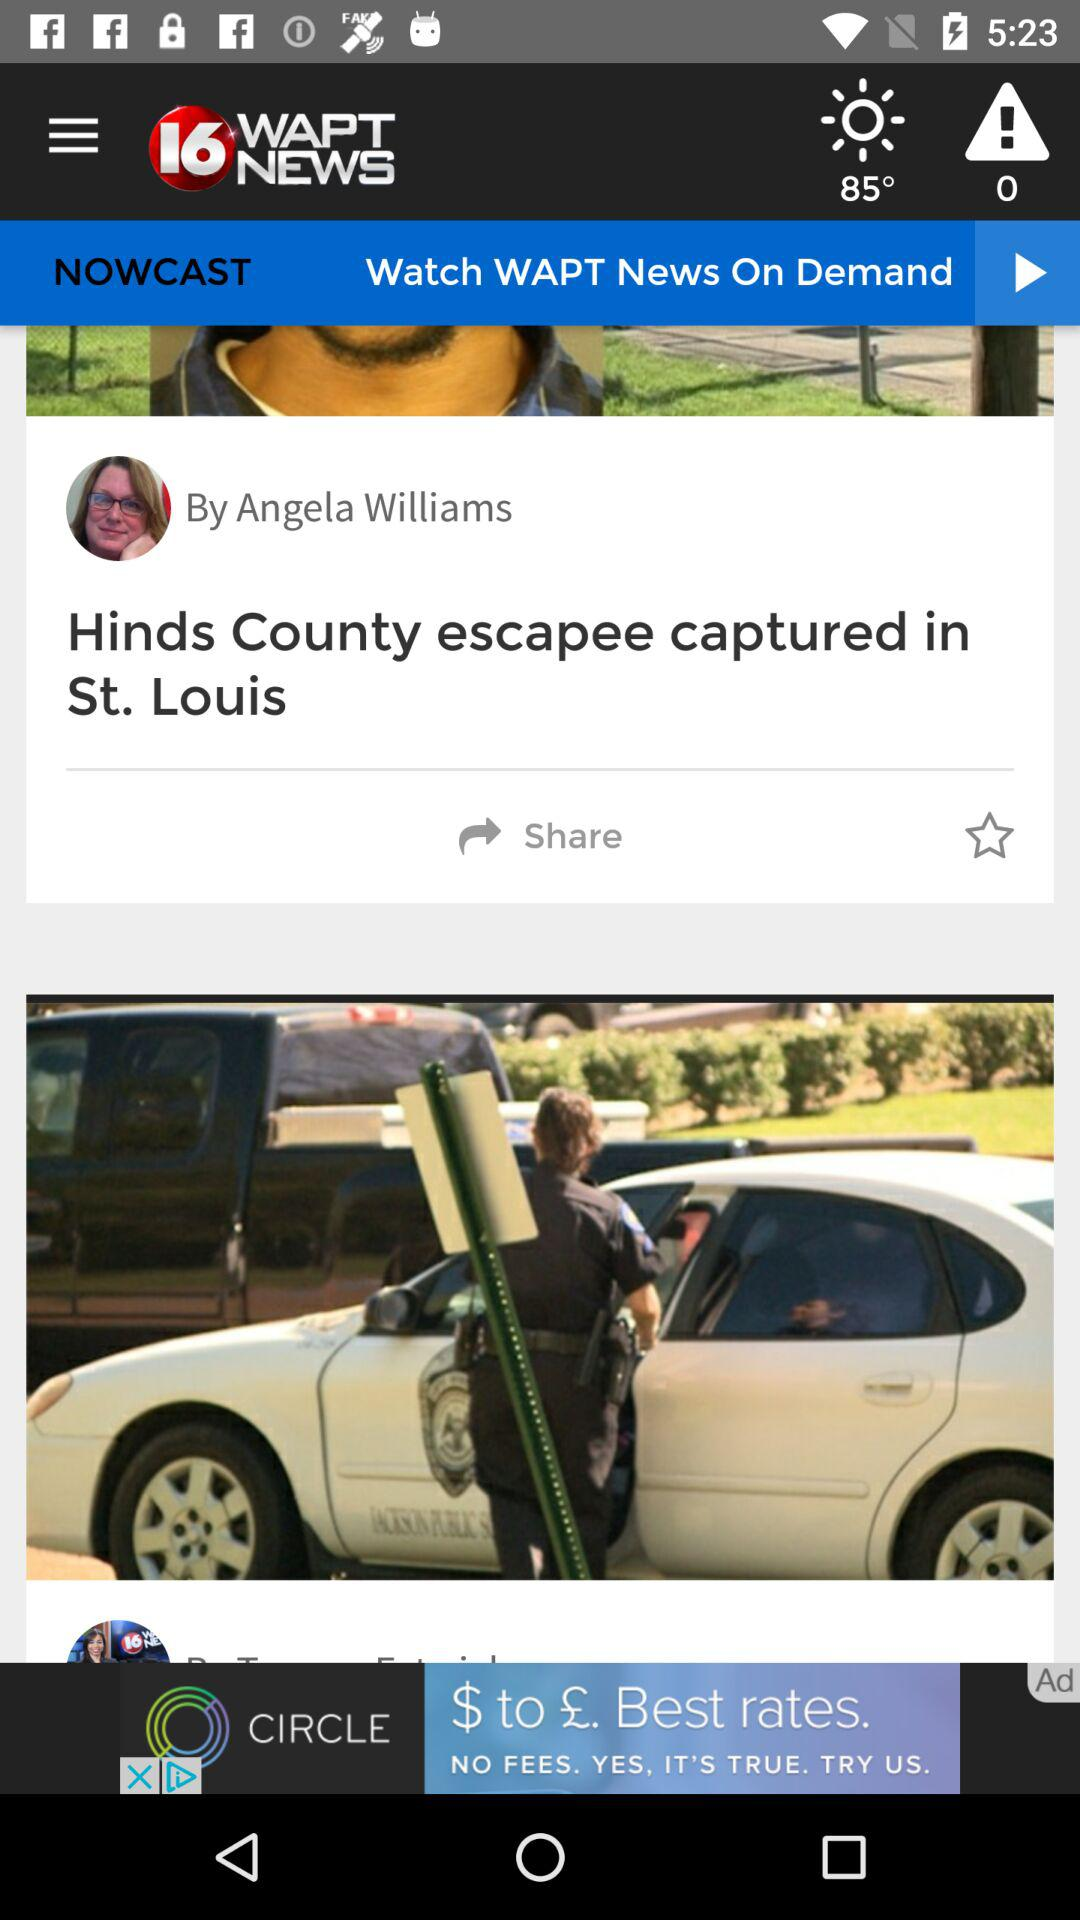What is the headline of the article? The headline of the article is "Hinds County escapee captured in St. Louis". 